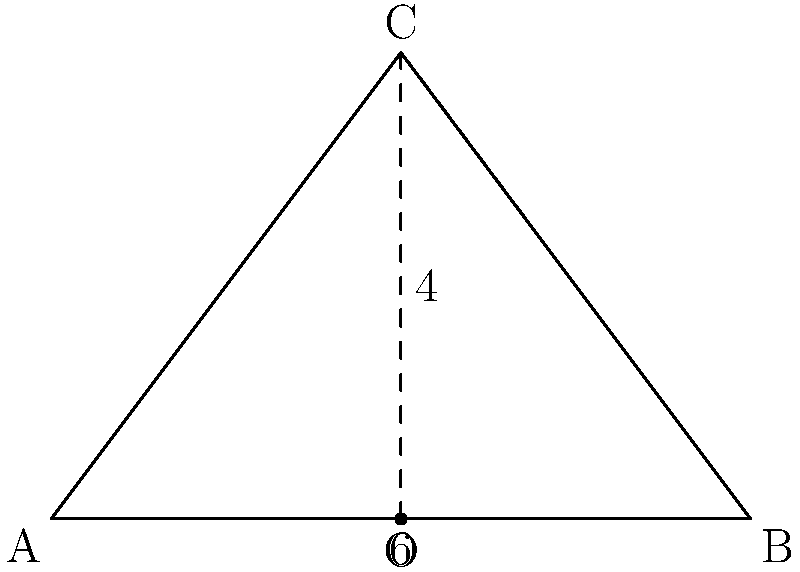In the isosceles triangle ABC shown above, the base AB is 6 units long, and the height CO is 4 units. What is the measure of angle BAC in degrees? Let's solve this step-by-step:

1) First, we need to recognize that in an isosceles triangle, the base angles are equal. So, angle BAC = angle BCA.

2) Let's call the measure of angle BAC as $x$. Since the sum of angles in a triangle is 180°, we can write:

   $2x + \angle ACB = 180°$

3) To find angle ACB, we can use the tangent function in the right triangle ACP:

   $\tan(\angle ACB/2) = \frac{4}{3}$

4) Taking the inverse tangent (arctan) of both sides:

   $\angle ACB/2 = \arctan(\frac{4}{3})$

5) Therefore:

   $\angle ACB = 2 \arctan(\frac{4}{3})$

6) Substituting this back into our equation from step 2:

   $2x + 2 \arctan(\frac{4}{3}) = 180°$

7) Solving for $x$:

   $x = 90° - \arctan(\frac{4}{3})$

8) Using a calculator or computer, we can evaluate this:

   $x \approx 53.13°$

Therefore, the measure of angle BAC is approximately 53.13°.
Answer: $53.13°$ 